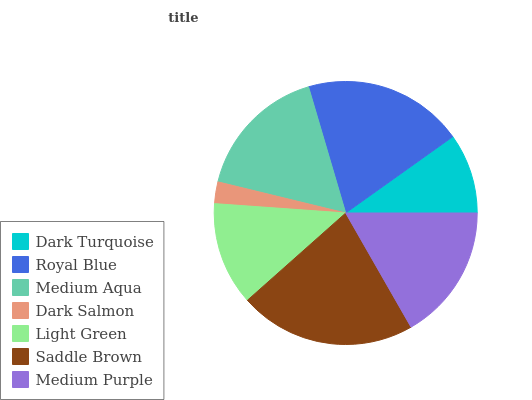Is Dark Salmon the minimum?
Answer yes or no. Yes. Is Saddle Brown the maximum?
Answer yes or no. Yes. Is Royal Blue the minimum?
Answer yes or no. No. Is Royal Blue the maximum?
Answer yes or no. No. Is Royal Blue greater than Dark Turquoise?
Answer yes or no. Yes. Is Dark Turquoise less than Royal Blue?
Answer yes or no. Yes. Is Dark Turquoise greater than Royal Blue?
Answer yes or no. No. Is Royal Blue less than Dark Turquoise?
Answer yes or no. No. Is Medium Aqua the high median?
Answer yes or no. Yes. Is Medium Aqua the low median?
Answer yes or no. Yes. Is Medium Purple the high median?
Answer yes or no. No. Is Dark Salmon the low median?
Answer yes or no. No. 